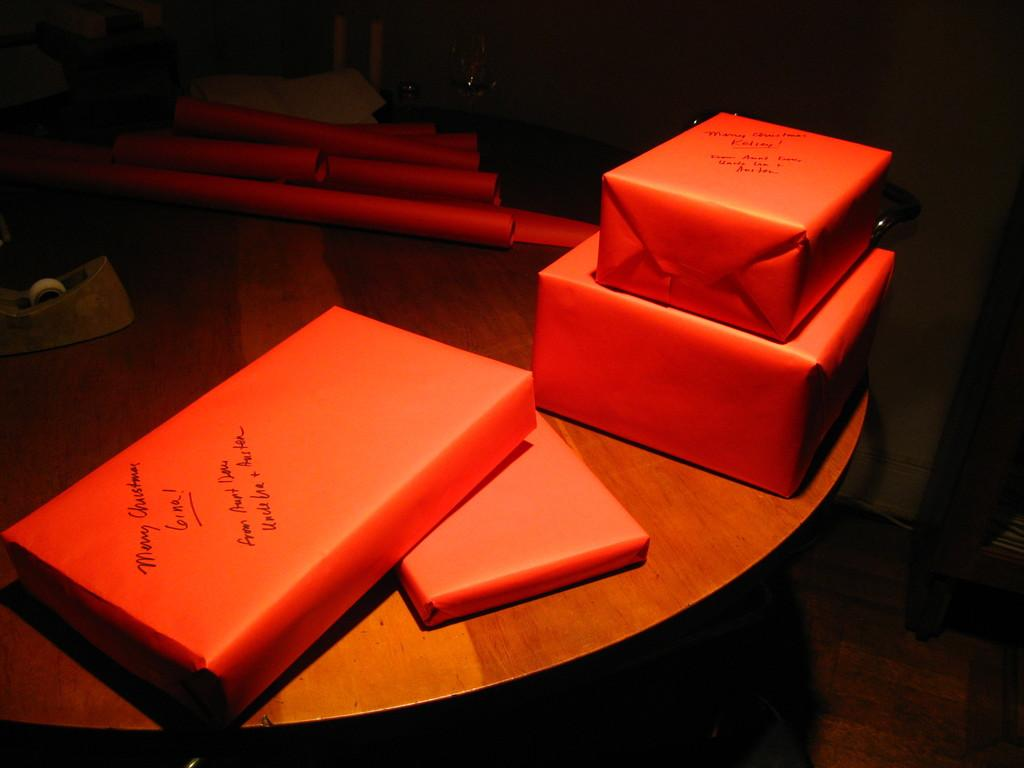<image>
Present a compact description of the photo's key features. wrappe up boxes with one labeled merry christmas gina! 